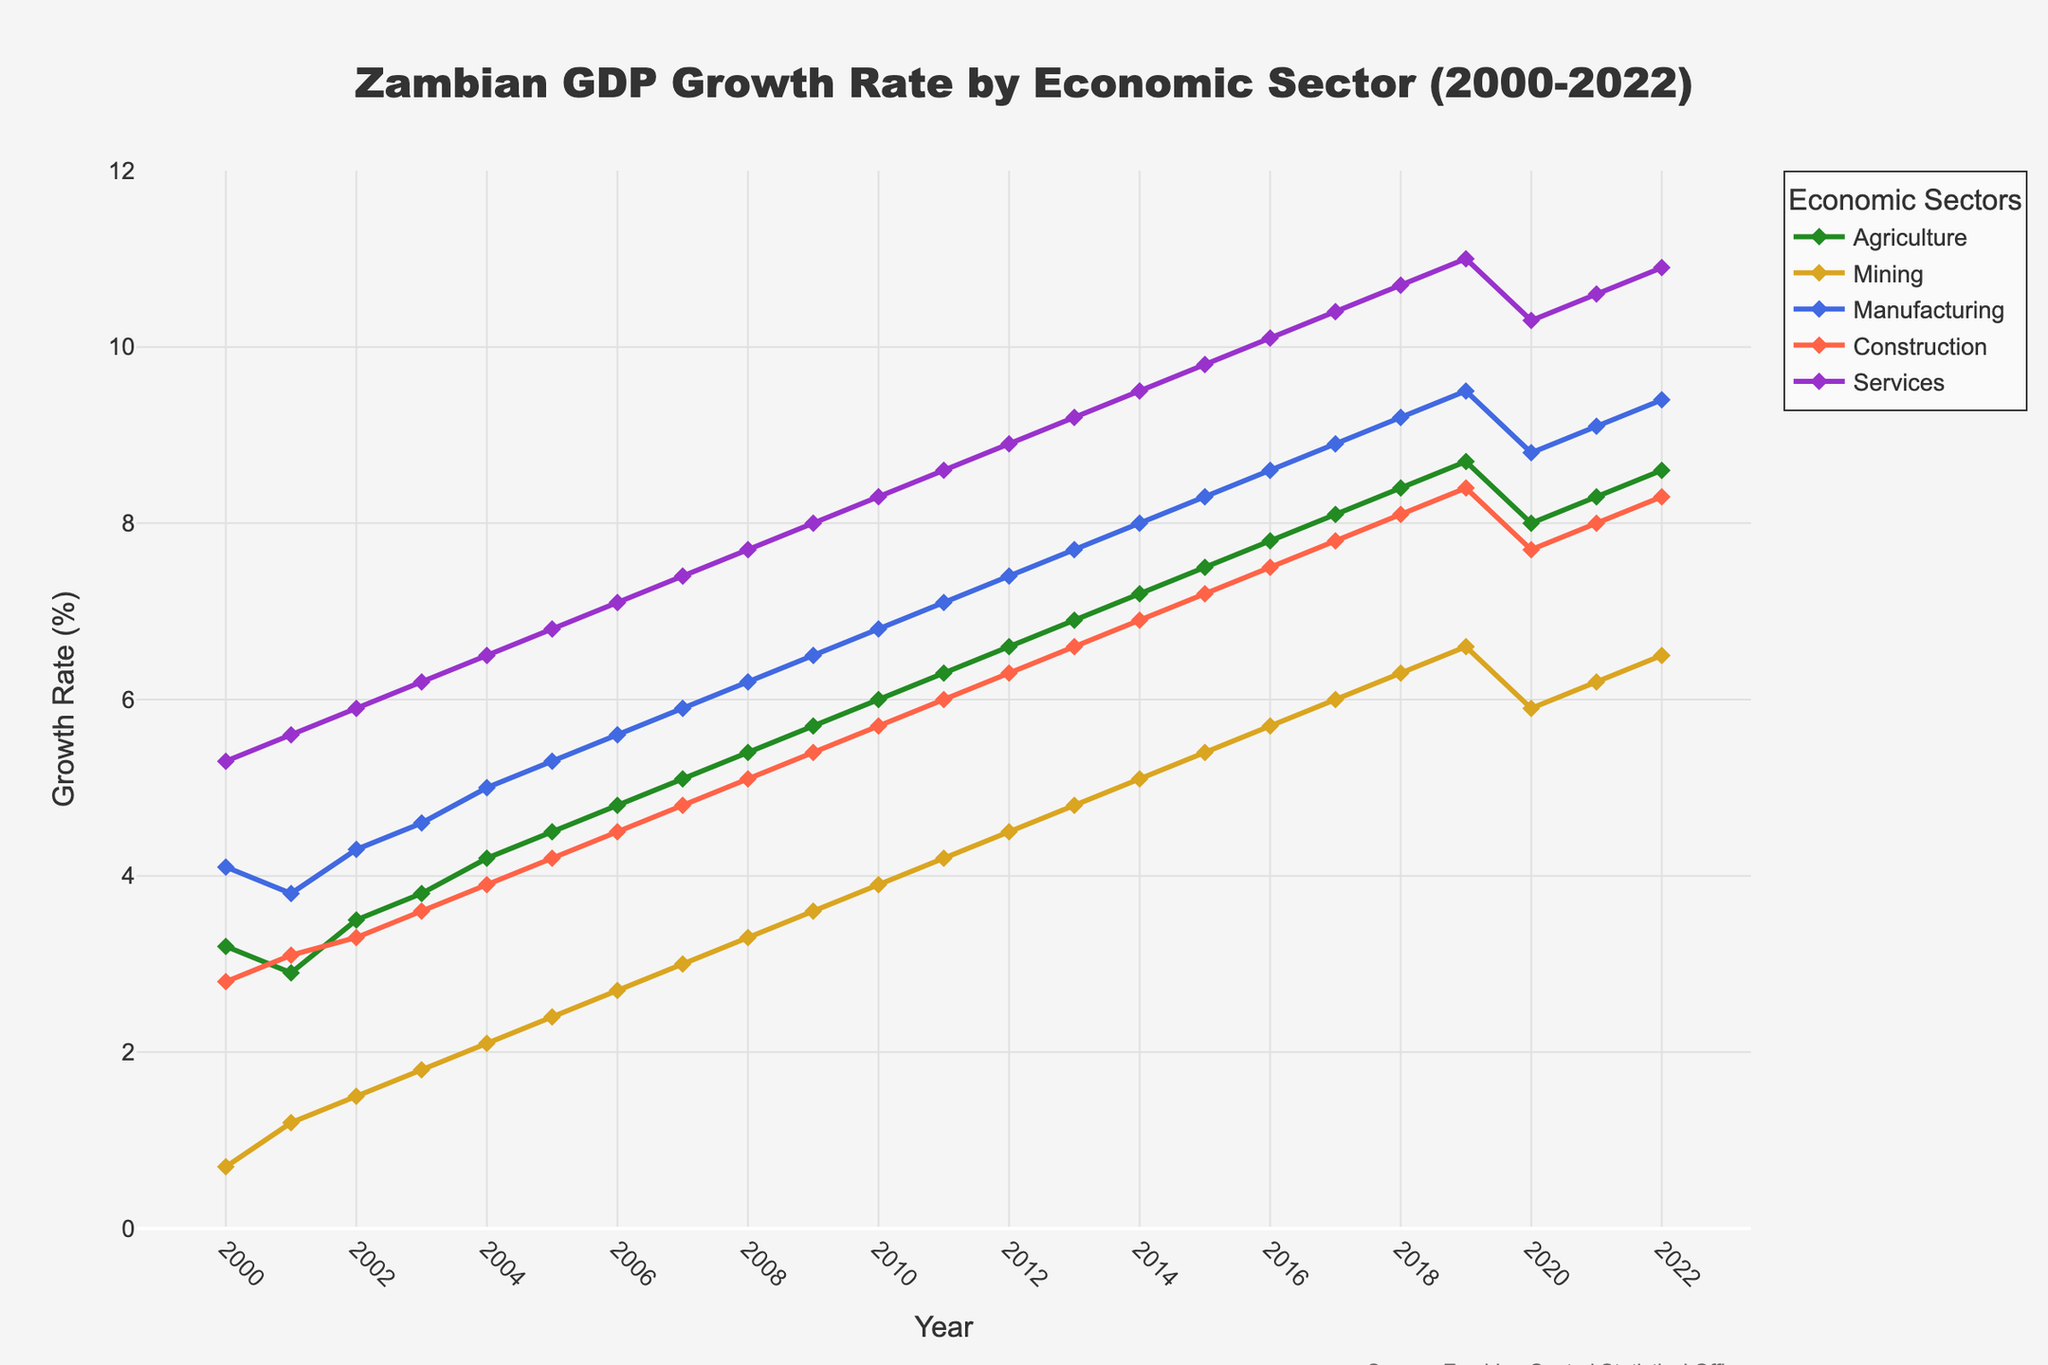What's the overall trend in the Services sector from 2000 to 2022? Look at the line representing the Services sector in the figure. It starts at 5.3% in 2000 and gradually increases to 10.9% in 2022, showing an upward trend.
Answer: Upward trend Which economic sector had the largest growth rate in any year during 2000-2022? By visually inspecting the highest peak in the chart, the Services sector reached the highest growth rate of 11.0% in 2019.
Answer: Services in 2019 Compare the growth rate of the Agriculture and Mining sectors in 2010. Which one is higher? Locate the points for Agriculture and Mining on the x-axis at 2010. Agriculture has a growth rate of 6.0%, whereas Mining has 3.9%. Therefore, Agriculture is higher.
Answer: Agriculture What is the difference between the highest and lowest growth rates in the Manufacturing sector between 2000 and 2020? Find the highest growth rate (9.5% in 2019) and the lowest growth rate (3.8% in 2001). The difference is 9.5% - 3.8% = 5.7%.
Answer: 5.7% Which sector had the most consistent growth (least fluctuation) throughout the years? By observing the smoothness and proximity of points in each line, the Services sector shows the most consistent, steady upward trend without large fluctuations.
Answer: Services In which year did the Construction sector first surpass a 7% growth rate? Trace the Construction sector line and find the year where it first crosses the 7% mark. It happens in 2015.
Answer: 2015 What was the average growth rate of the Mining sector over the years 2000-2022? Sum the growth rates from 2000 to 2022 for Mining and then divide by the number of years (23). The calculation is (0.7+1.2+1.5+1.8+2.1+2.4+2.7+3.0+3.3+3.6+3.9+4.2+4.5+4.8+5.1+5.4+5.7+6.0+6.3+6.6+5.9+6.2+6.5)/23 = approximately 4.0%.
Answer: 4.0% During which year did the Agriculture sector experience its largest year-over-year increase? Compare year-over-year changes visually and identify the largest gap between points for Agriculture. The increase from 2001 (2.9%) to 2002 (3.5%) is the largest, which is 3.5% - 2.9% = 0.6%.
Answer: 2002 Between 2020 and 2022, which sectors experienced a decrease in growth rate? Look at the lines from 2020 to 2022 and observe any downward slopes. Agriculture experienced a decrease from 8.0% in 2020 to 8.3% in 2021 and up again in 2022. Services also slightly dropped from 10.3% in 2020 to 10.6% in 2021, then increased to 10.9% in 2022.
Answer: Agriculture, Services 